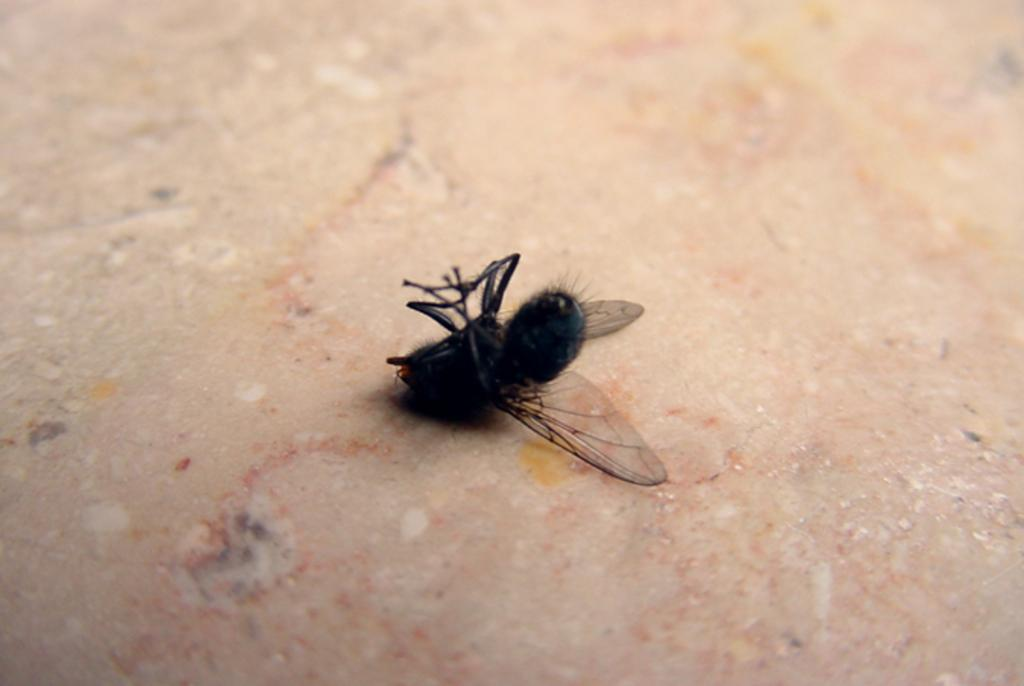What type of creature is present in the image? There is an insect in the image. Where is the insect located in the image? The insect is on a surface. What type of metal is the beam made of in the image? There is no beam present in the image, and therefore no metal can be identified. 